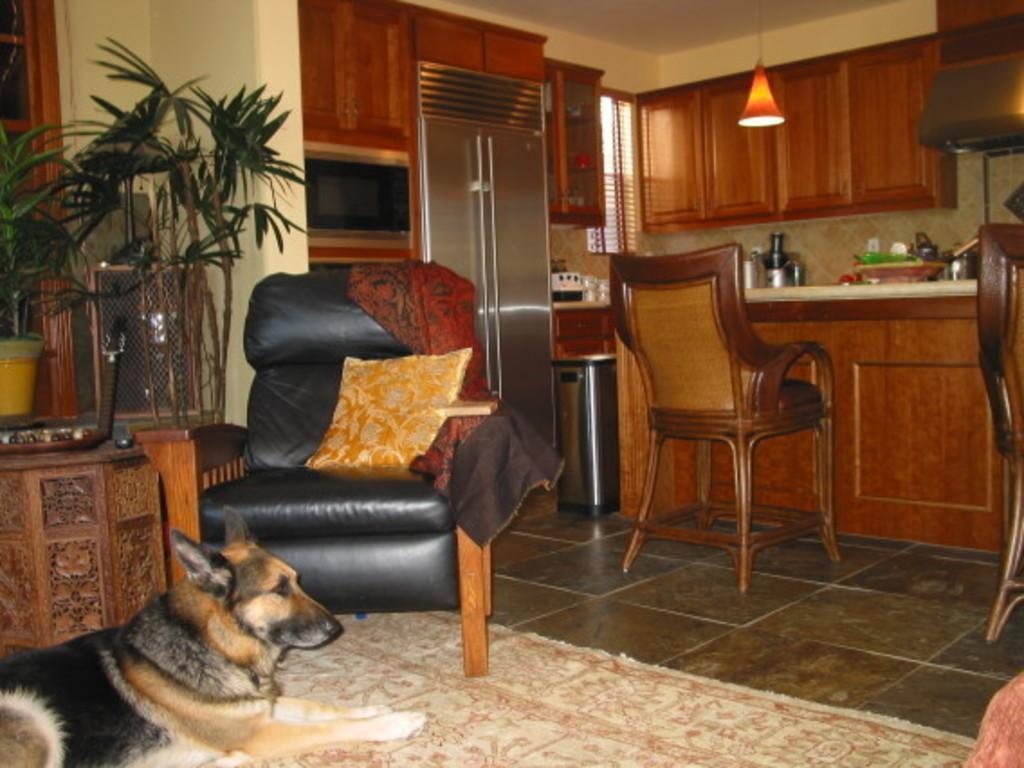In one or two sentences, can you explain what this image depicts? This picture is consists of a room where there is a sofa at the left side of the image and a chair at the center of the image, there are cupboards all around the area of the image and kitchenware on the desk at the right side of the image there is rug on the floor on which a dog is sitting and there is a flower pot at the left side of the image and there is a pillow on the sofa. 